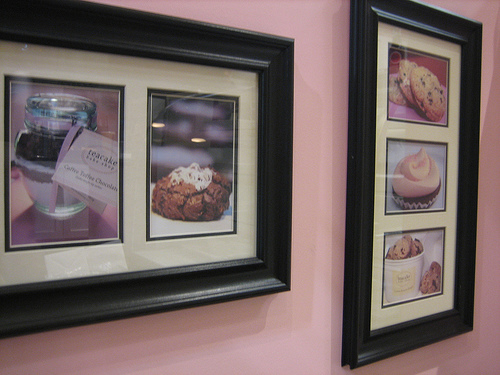<image>
Is the wall behind the photo frame? Yes. From this viewpoint, the wall is positioned behind the photo frame, with the photo frame partially or fully occluding the wall. 